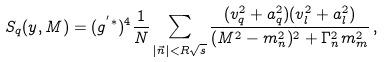Convert formula to latex. <formula><loc_0><loc_0><loc_500><loc_500>S _ { q } ( y , M ) = ( g ^ { ^ { \prime } * } ) ^ { 4 } \frac { 1 } { N } \sum _ { | \vec { n } | < R \sqrt { s } } \frac { ( v ^ { 2 } _ { q } + a ^ { 2 } _ { q } ) ( v ^ { 2 } _ { l } + a ^ { 2 } _ { l } ) } { ( M ^ { 2 } - m ^ { 2 } _ { n } ) ^ { 2 } + \Gamma ^ { 2 } _ { n } m ^ { 2 } _ { m } } \, ,</formula> 